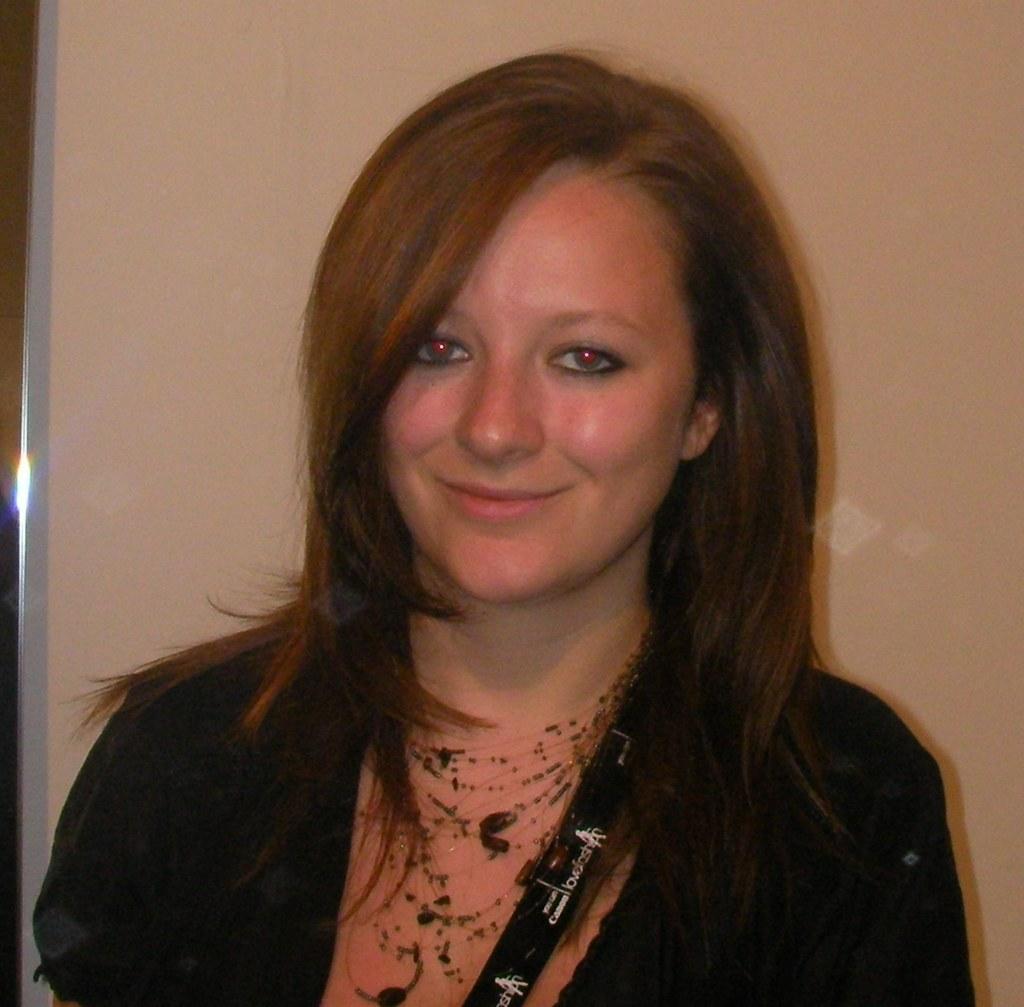In one or two sentences, can you explain what this image depicts? This image is taken indoors. In the background there is a wall. In the middle of the image there is a woman with a smiling face. 